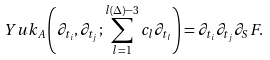<formula> <loc_0><loc_0><loc_500><loc_500>Y u k _ { A } \left ( \partial _ { t _ { i } } , \partial _ { t _ { j } } ; \sum _ { l = 1 } ^ { l ( \Delta ) - 3 } c _ { l } \partial _ { t _ { l } } \right ) = \partial _ { t _ { i } } \partial _ { t _ { j } } \partial _ { S } F .</formula> 